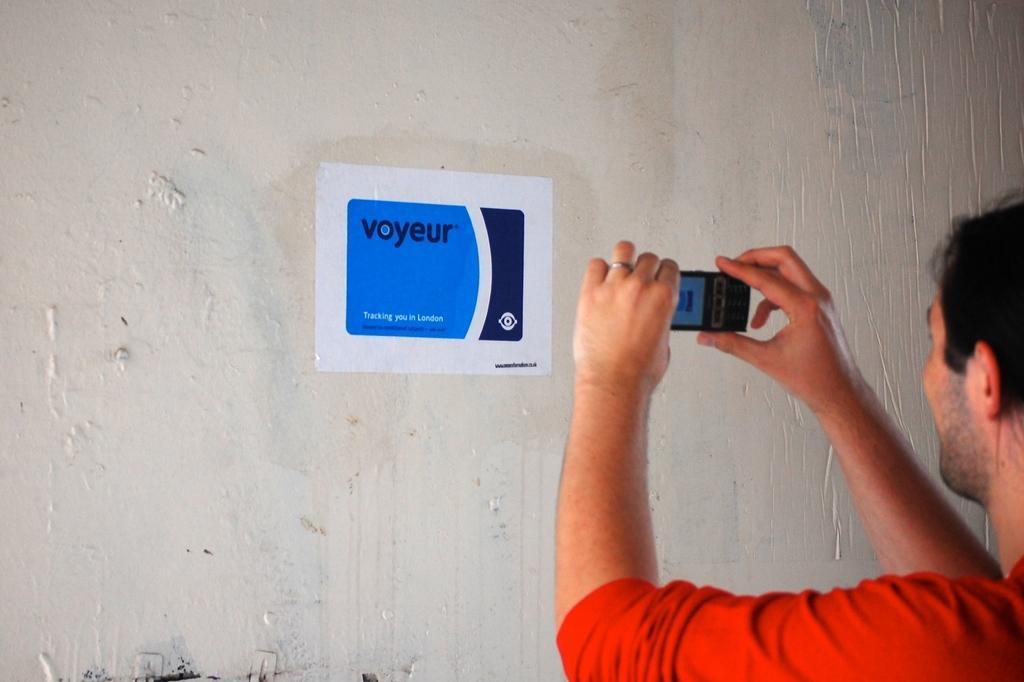In one or two sentences, can you explain what this image depicts? A person is holding a mobile. Poster is on white wall. 